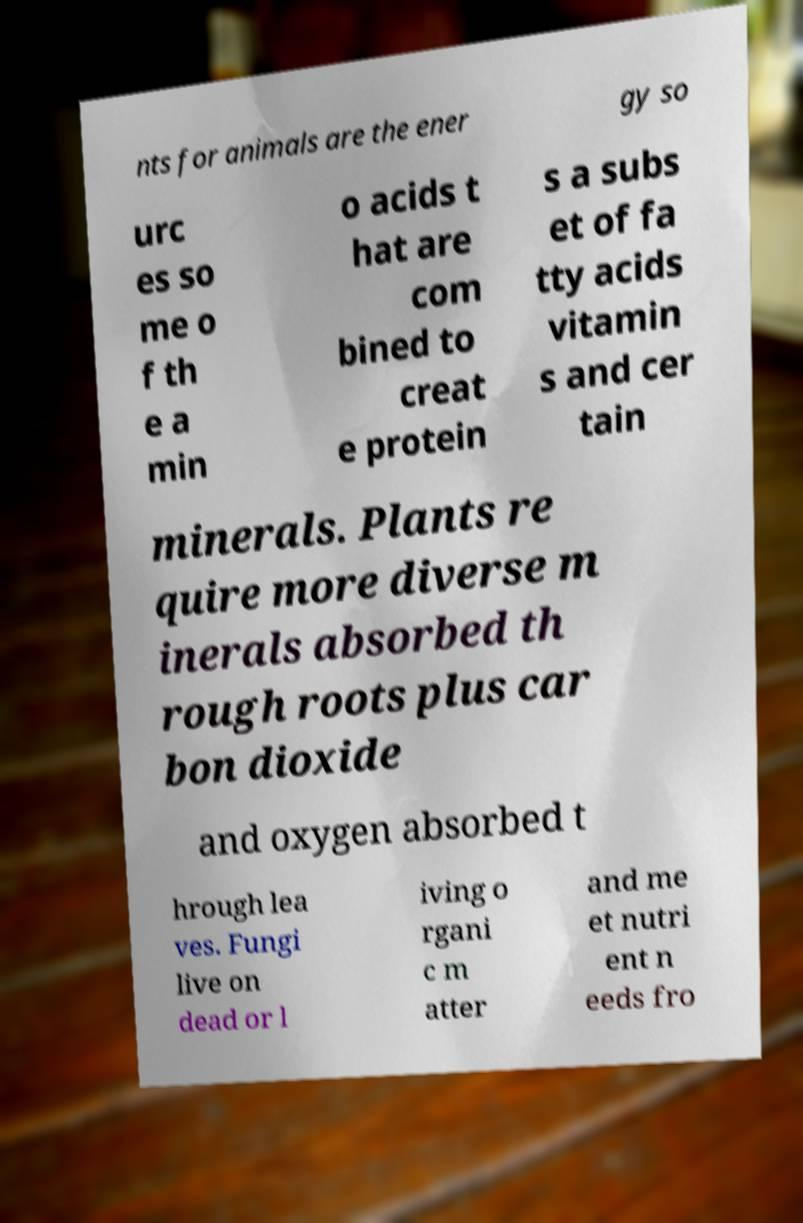Can you accurately transcribe the text from the provided image for me? nts for animals are the ener gy so urc es so me o f th e a min o acids t hat are com bined to creat e protein s a subs et of fa tty acids vitamin s and cer tain minerals. Plants re quire more diverse m inerals absorbed th rough roots plus car bon dioxide and oxygen absorbed t hrough lea ves. Fungi live on dead or l iving o rgani c m atter and me et nutri ent n eeds fro 